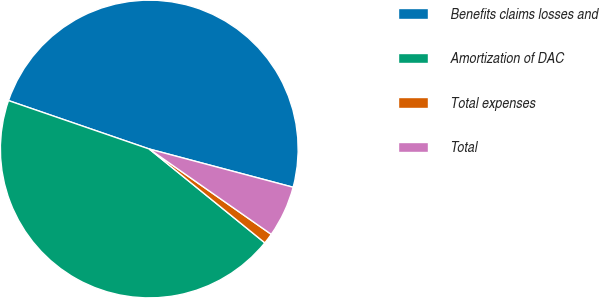Convert chart. <chart><loc_0><loc_0><loc_500><loc_500><pie_chart><fcel>Benefits claims losses and<fcel>Amortization of DAC<fcel>Total expenses<fcel>Total<nl><fcel>48.86%<fcel>44.42%<fcel>1.14%<fcel>5.58%<nl></chart> 